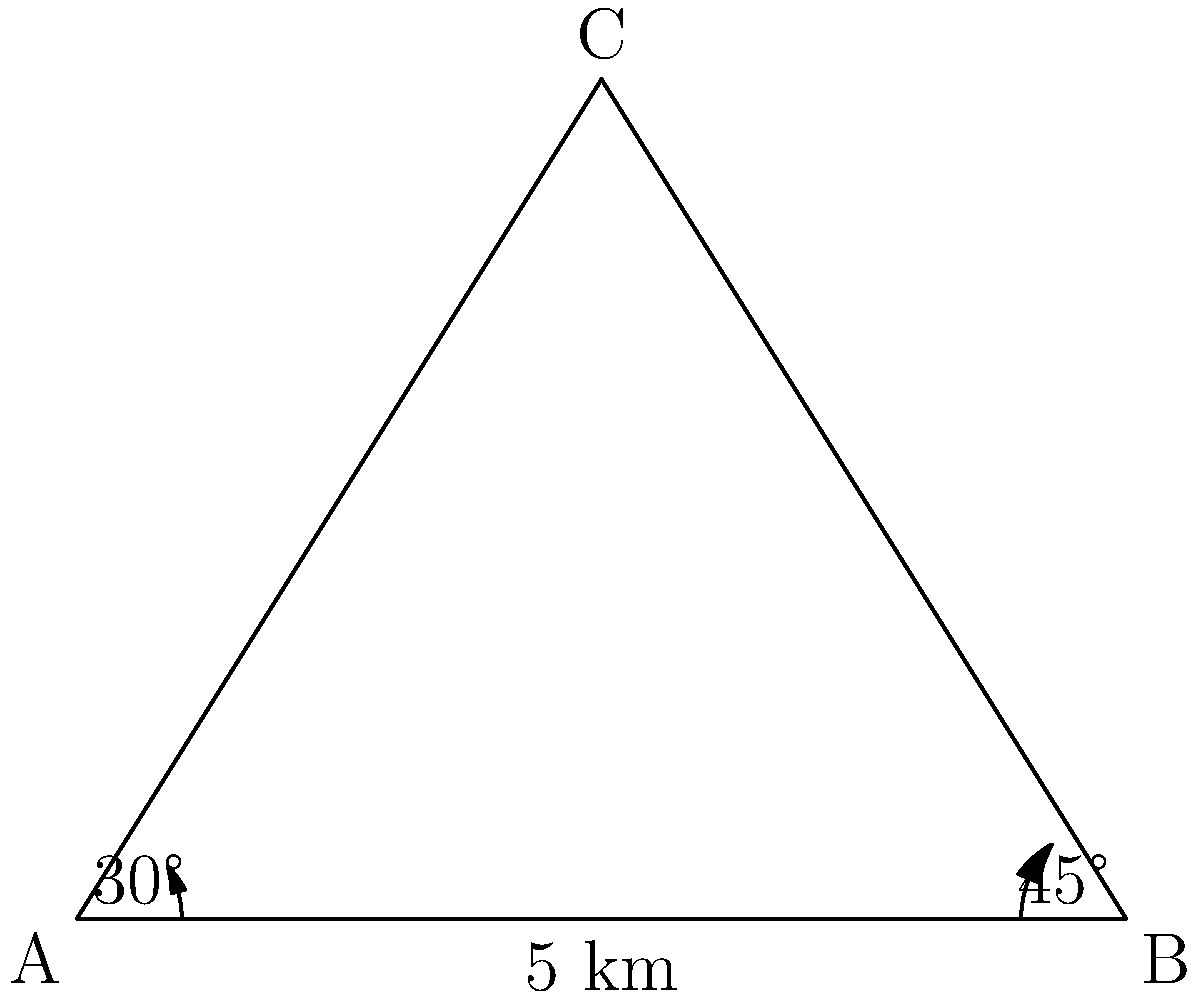Two patrol units, A and B, are stationed 5 km apart along a straight road. They both observe a suspicious activity at point C. The angle between the line of sight to C and the road is 30° for unit A and 45° for unit B. Calculate the distance between unit A and point C. Let's solve this problem step by step using the law of sines:

1) First, let's identify what we know:
   - The distance between A and B is 5 km
   - The angle at A is 30°
   - The angle at B is 45°

2) We can find the third angle of the triangle:
   $180° - 30° - 45° = 105°$

3) Now we can use the law of sines:
   $$\frac{a}{\sin A} = \frac{b}{\sin B} = \frac{c}{\sin C}$$

   Where $a$, $b$, and $c$ are the sides opposite to angles A, B, and C respectively.

4) We want to find the distance AC (let's call it $x$). We know AB (5 km) and all angles:
   $$\frac{x}{\sin 45°} = \frac{5}{\sin 105°}$$

5) Solve for $x$:
   $$x = \frac{5 \sin 45°}{\sin 105°}$$

6) Calculate:
   $$x = \frac{5 \cdot 0.7071}{0.9659} \approx 3.66 \text{ km}$$

Therefore, the distance between unit A and point C is approximately 3.66 km.
Answer: 3.66 km 